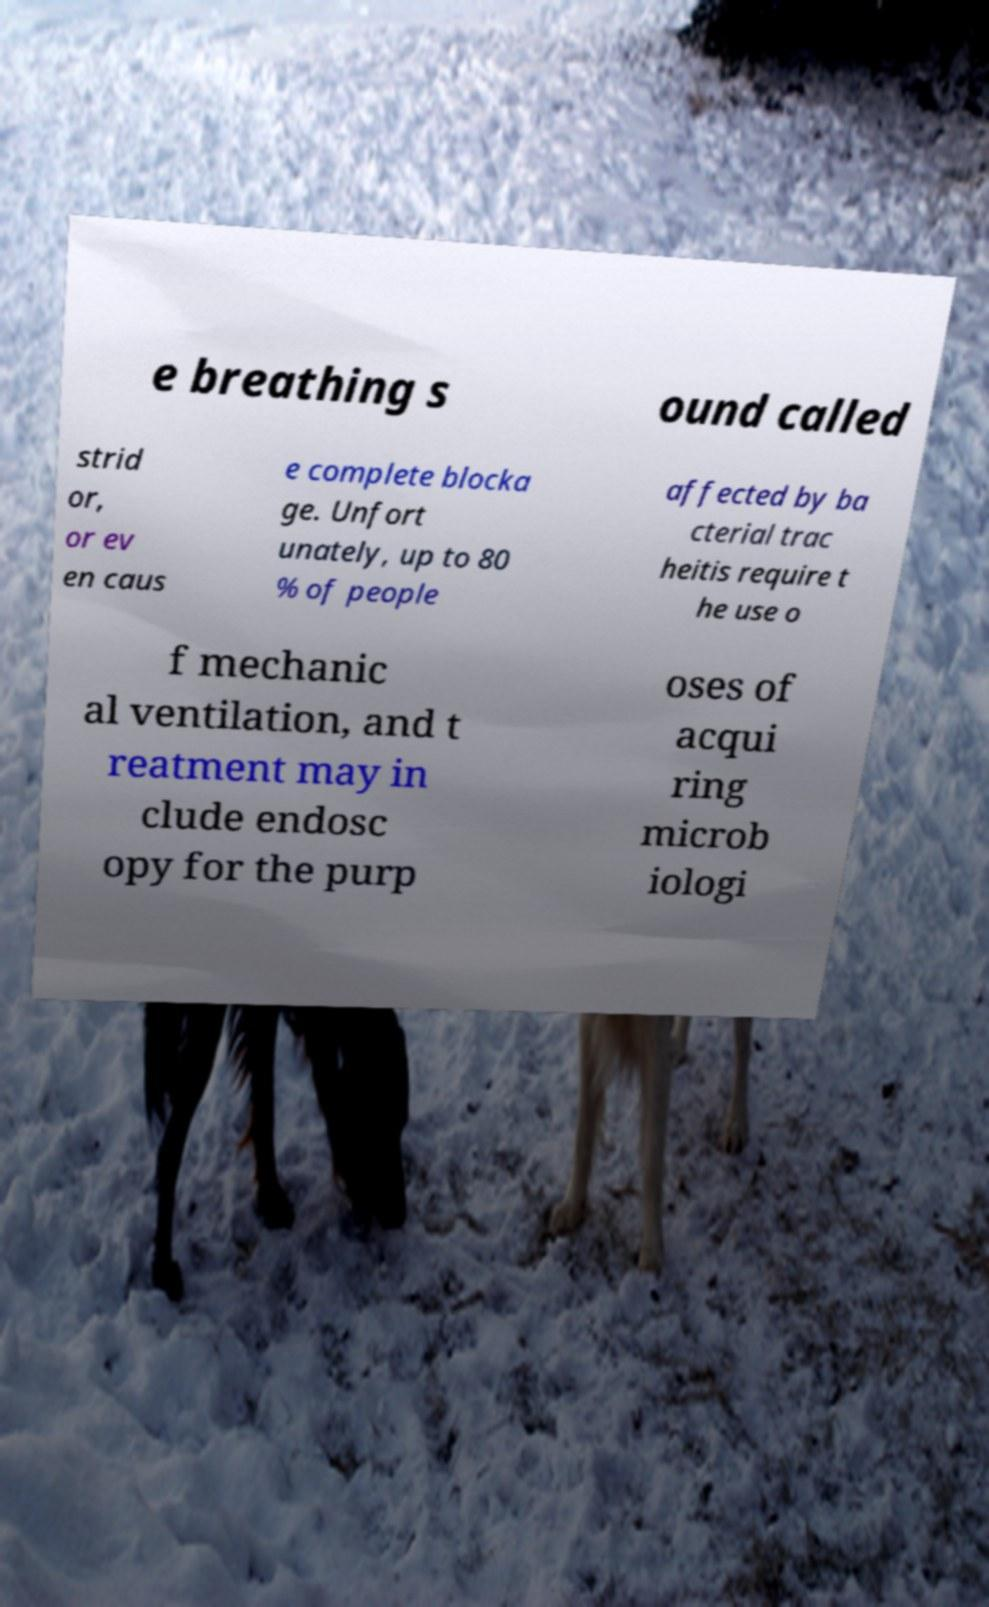Could you extract and type out the text from this image? e breathing s ound called strid or, or ev en caus e complete blocka ge. Unfort unately, up to 80 % of people affected by ba cterial trac heitis require t he use o f mechanic al ventilation, and t reatment may in clude endosc opy for the purp oses of acqui ring microb iologi 